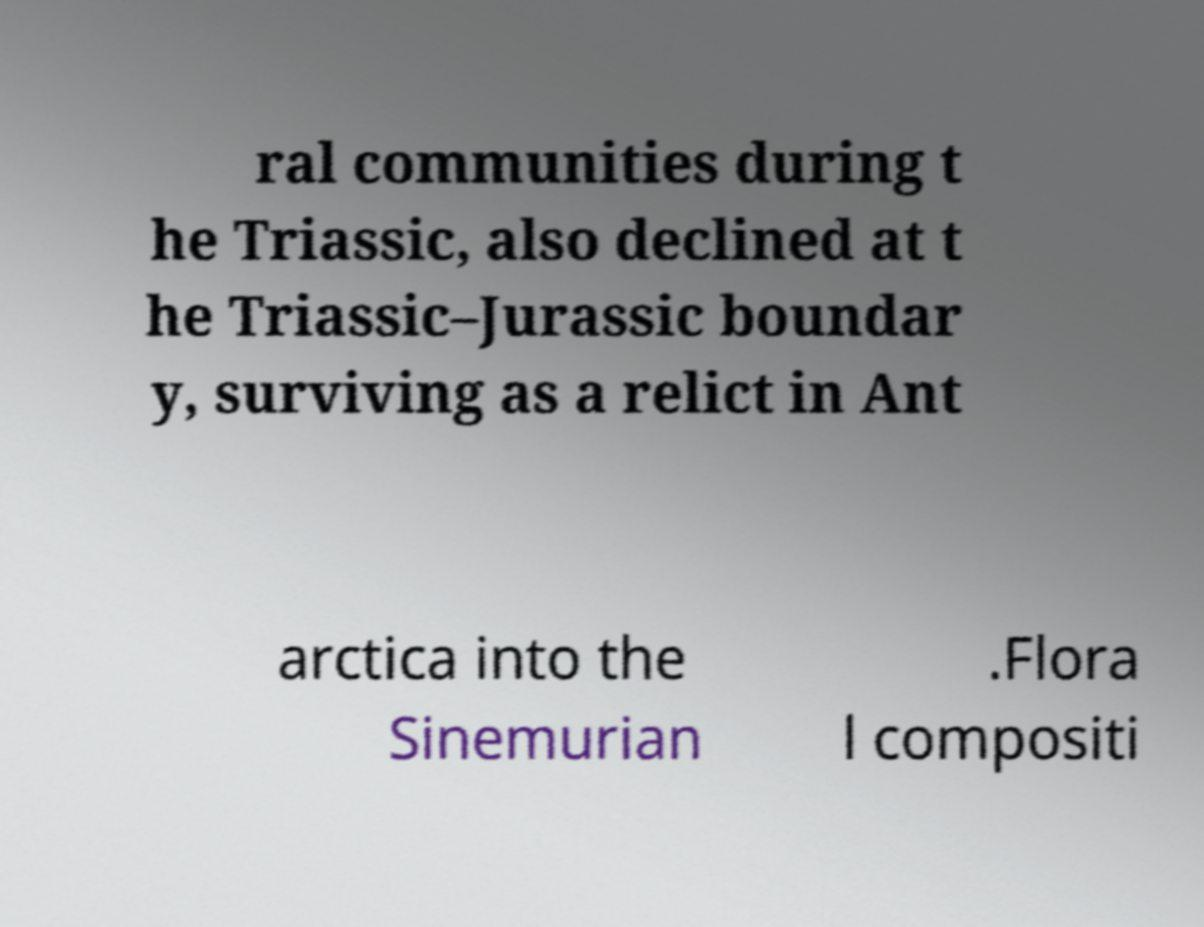Please read and relay the text visible in this image. What does it say? ral communities during t he Triassic, also declined at t he Triassic–Jurassic boundar y, surviving as a relict in Ant arctica into the Sinemurian .Flora l compositi 